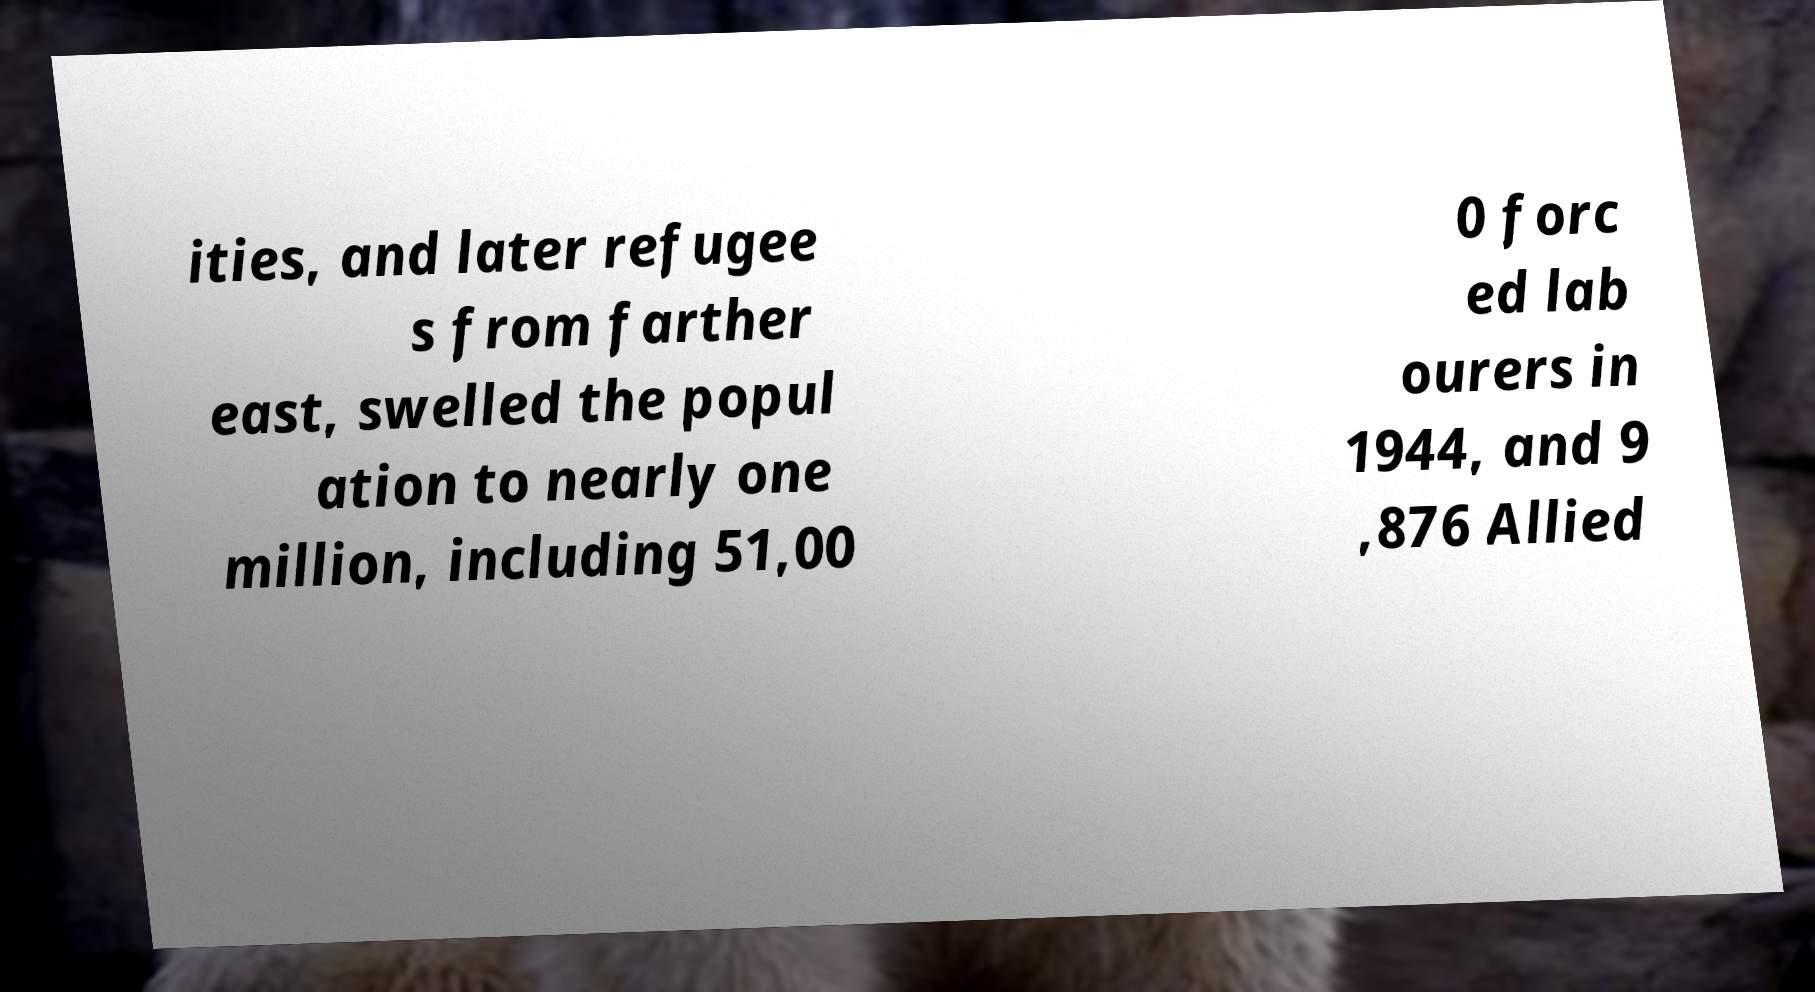Could you assist in decoding the text presented in this image and type it out clearly? ities, and later refugee s from farther east, swelled the popul ation to nearly one million, including 51,00 0 forc ed lab ourers in 1944, and 9 ,876 Allied 